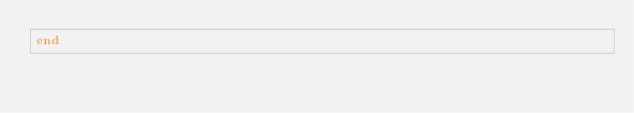Convert code to text. <code><loc_0><loc_0><loc_500><loc_500><_Crystal_>end
</code> 